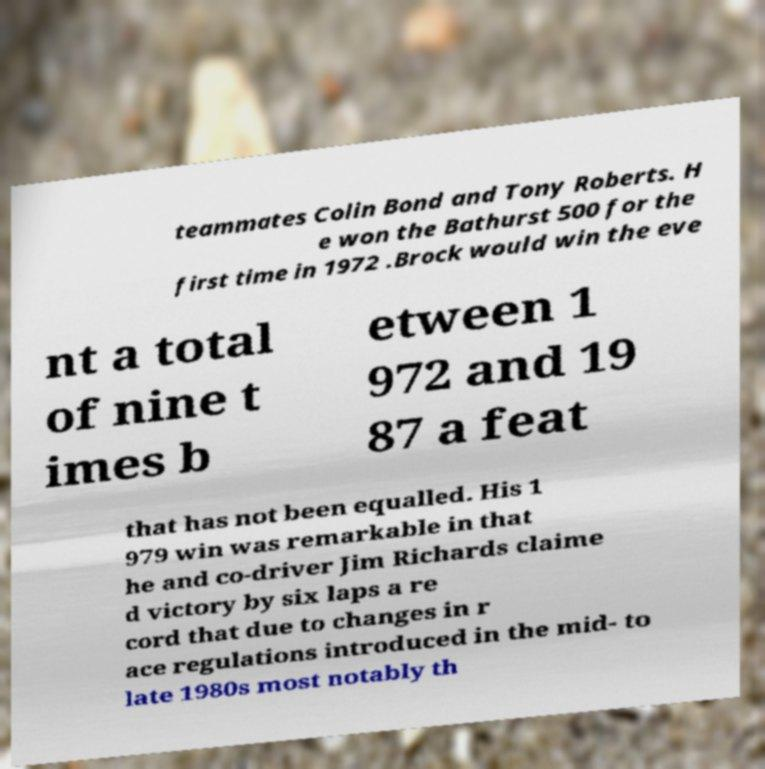What messages or text are displayed in this image? I need them in a readable, typed format. teammates Colin Bond and Tony Roberts. H e won the Bathurst 500 for the first time in 1972 .Brock would win the eve nt a total of nine t imes b etween 1 972 and 19 87 a feat that has not been equalled. His 1 979 win was remarkable in that he and co-driver Jim Richards claime d victory by six laps a re cord that due to changes in r ace regulations introduced in the mid- to late 1980s most notably th 